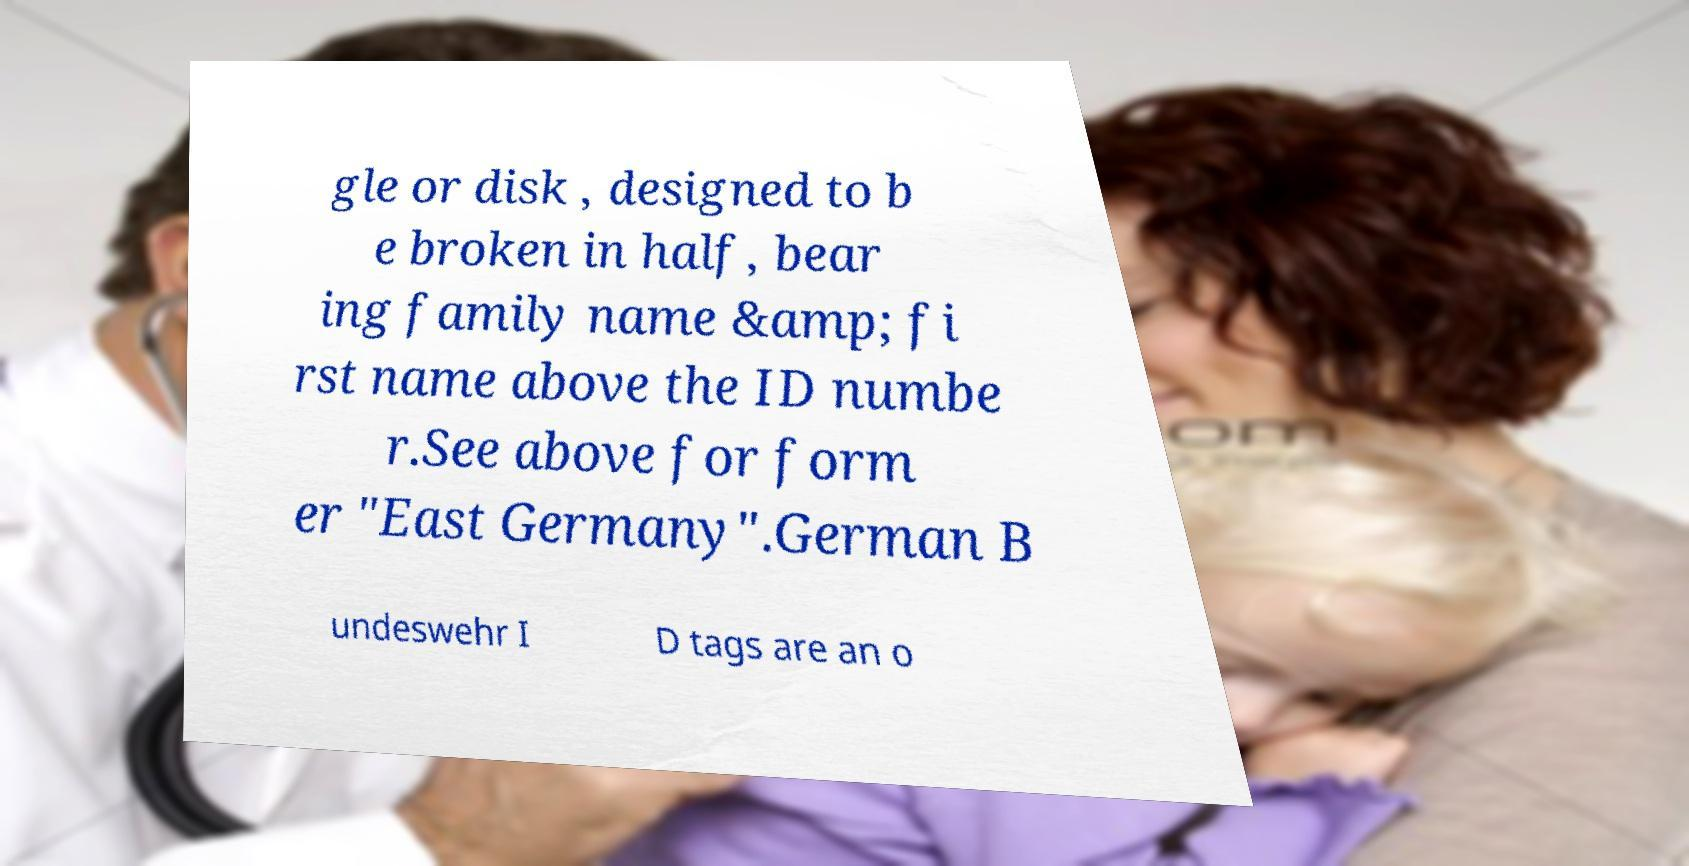Please identify and transcribe the text found in this image. gle or disk , designed to b e broken in half, bear ing family name &amp; fi rst name above the ID numbe r.See above for form er "East Germany".German B undeswehr I D tags are an o 